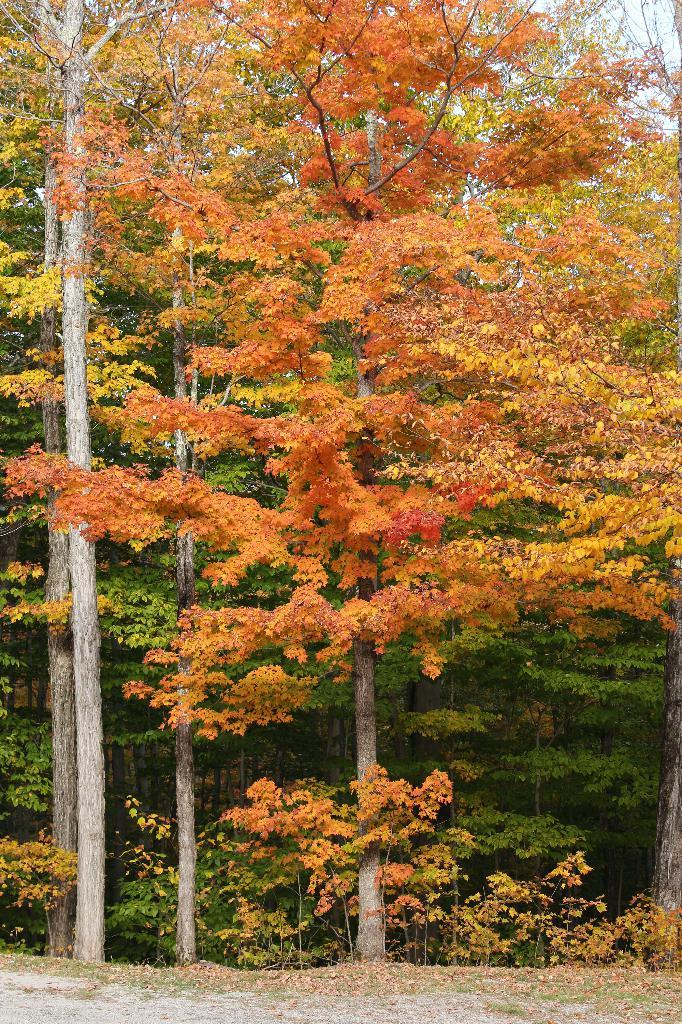What can be seen at the top of the image? The sky is visible towards the top of the image. What type of vegetation is present in the image? There are trees and plants in the image. What is visible at the bottom of the image? The ground is visible towards the bottom of the image. Can you see any cherries hanging from the trees in the image? There is no mention of cherries in the image, so we cannot determine if they are present or not. Is the moon visible in the image? The provided facts do not mention the moon, so we cannot determine if it is visible or not. 